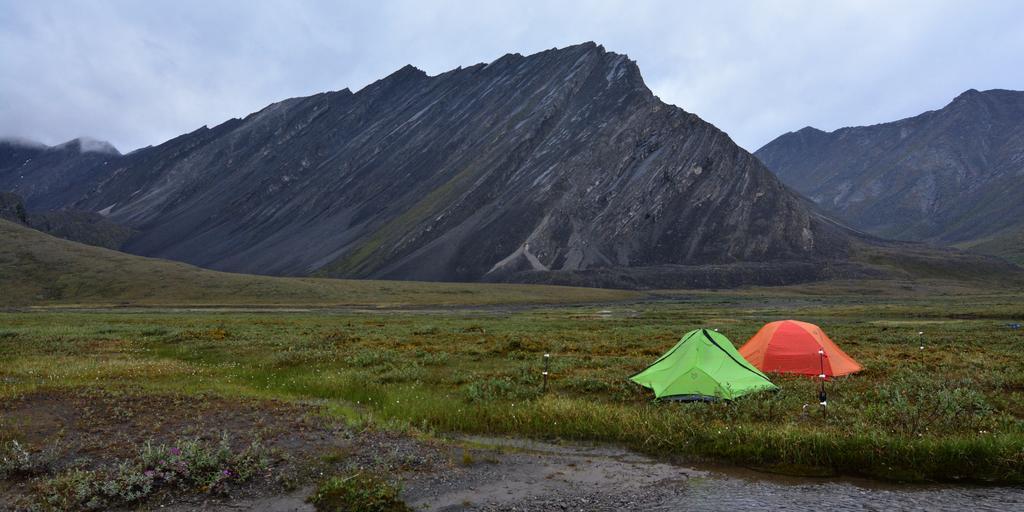Could you give a brief overview of what you see in this image? In this picture we can observe green and orange color tents on the ground. We can observe some plants on the ground. In the background we can observe hills and a sky with some clouds. 